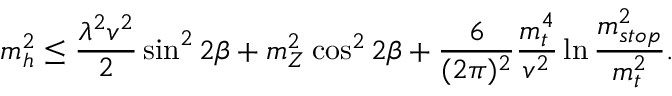<formula> <loc_0><loc_0><loc_500><loc_500>m _ { h } ^ { 2 } \leq \frac { \lambda ^ { 2 } v ^ { 2 } } { 2 } \sin ^ { 2 } { 2 \beta } + m _ { Z } ^ { 2 } \cos ^ { 2 } { 2 \beta } + \frac { 6 } { ( 2 \pi ) ^ { 2 } } \frac { m _ { t } ^ { 4 } } { v ^ { 2 } } \ln { \frac { m _ { s t o p } ^ { 2 } } { m _ { t } ^ { 2 } } } .</formula> 